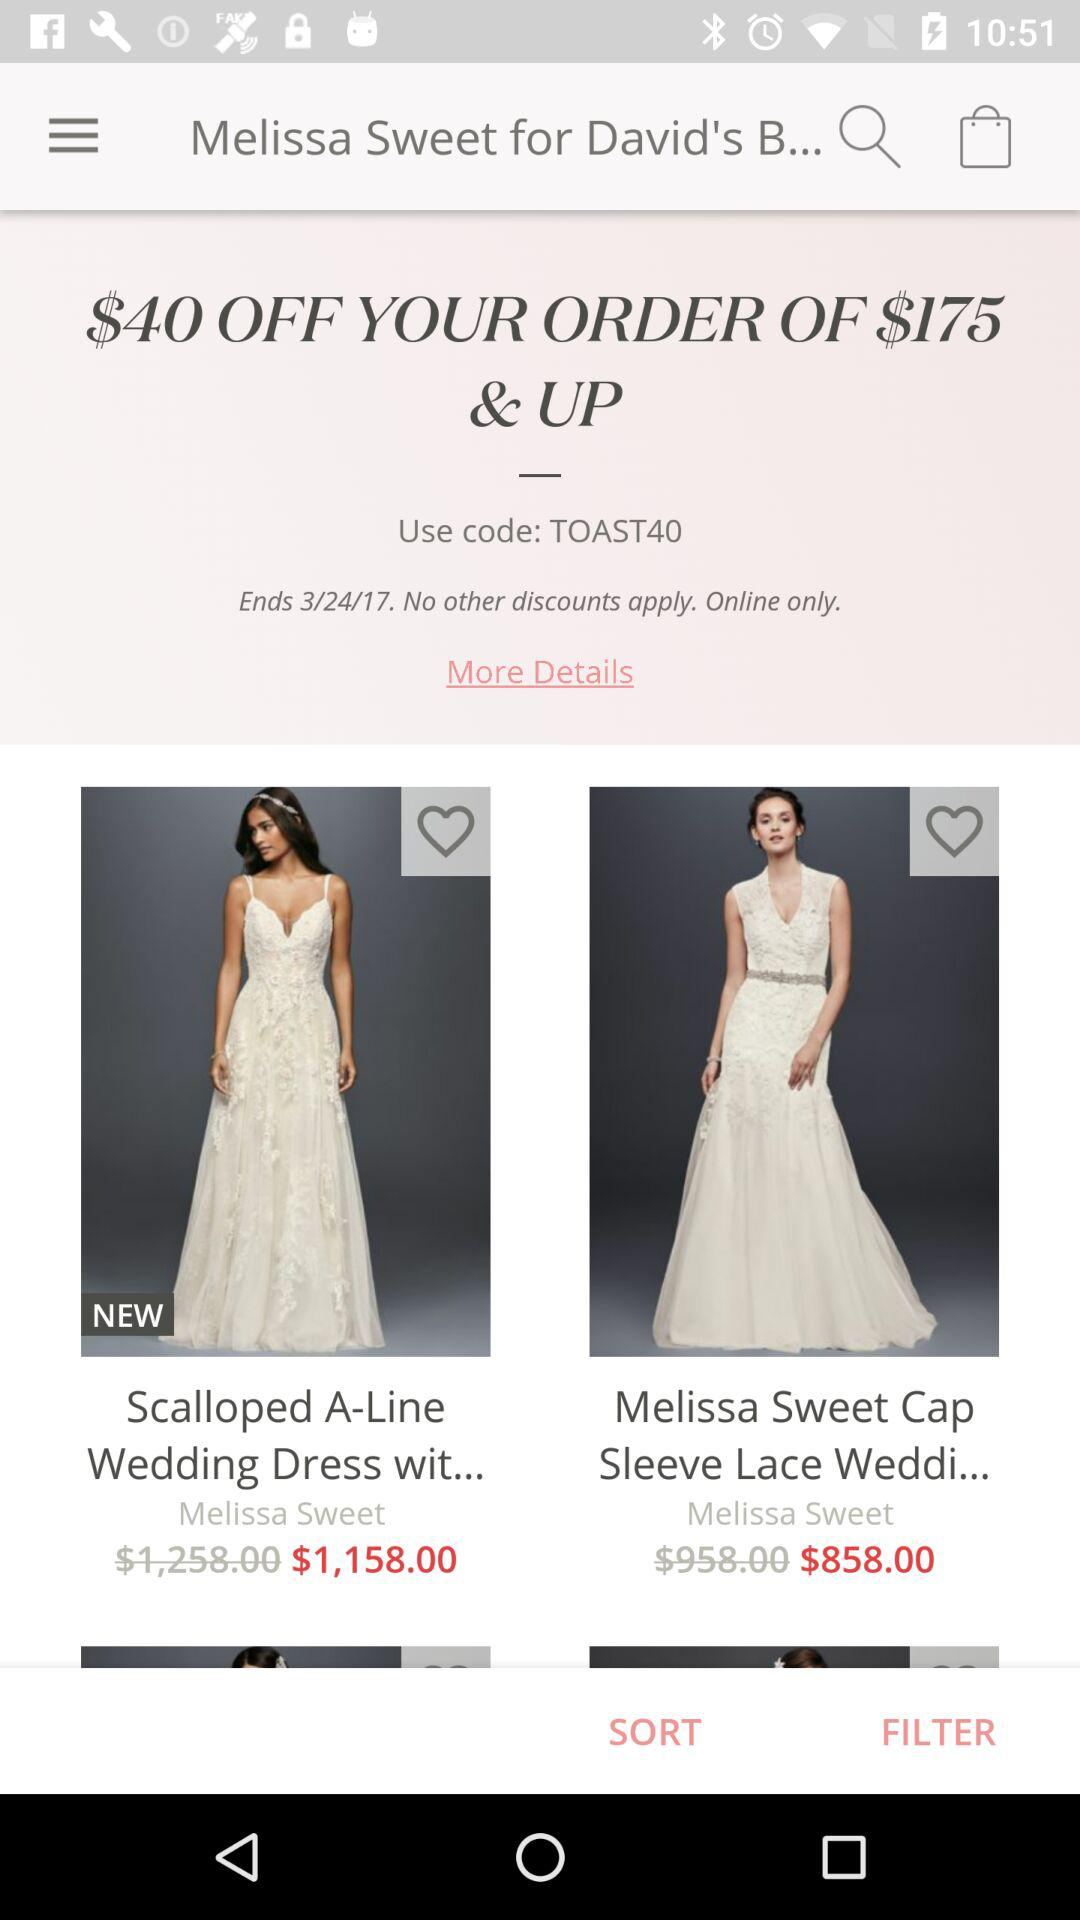What is the price of the "Scalloped A-Line Wedding Dress"? The price of the "Scalloped A-Line Wedding Dress" is $1,158. 